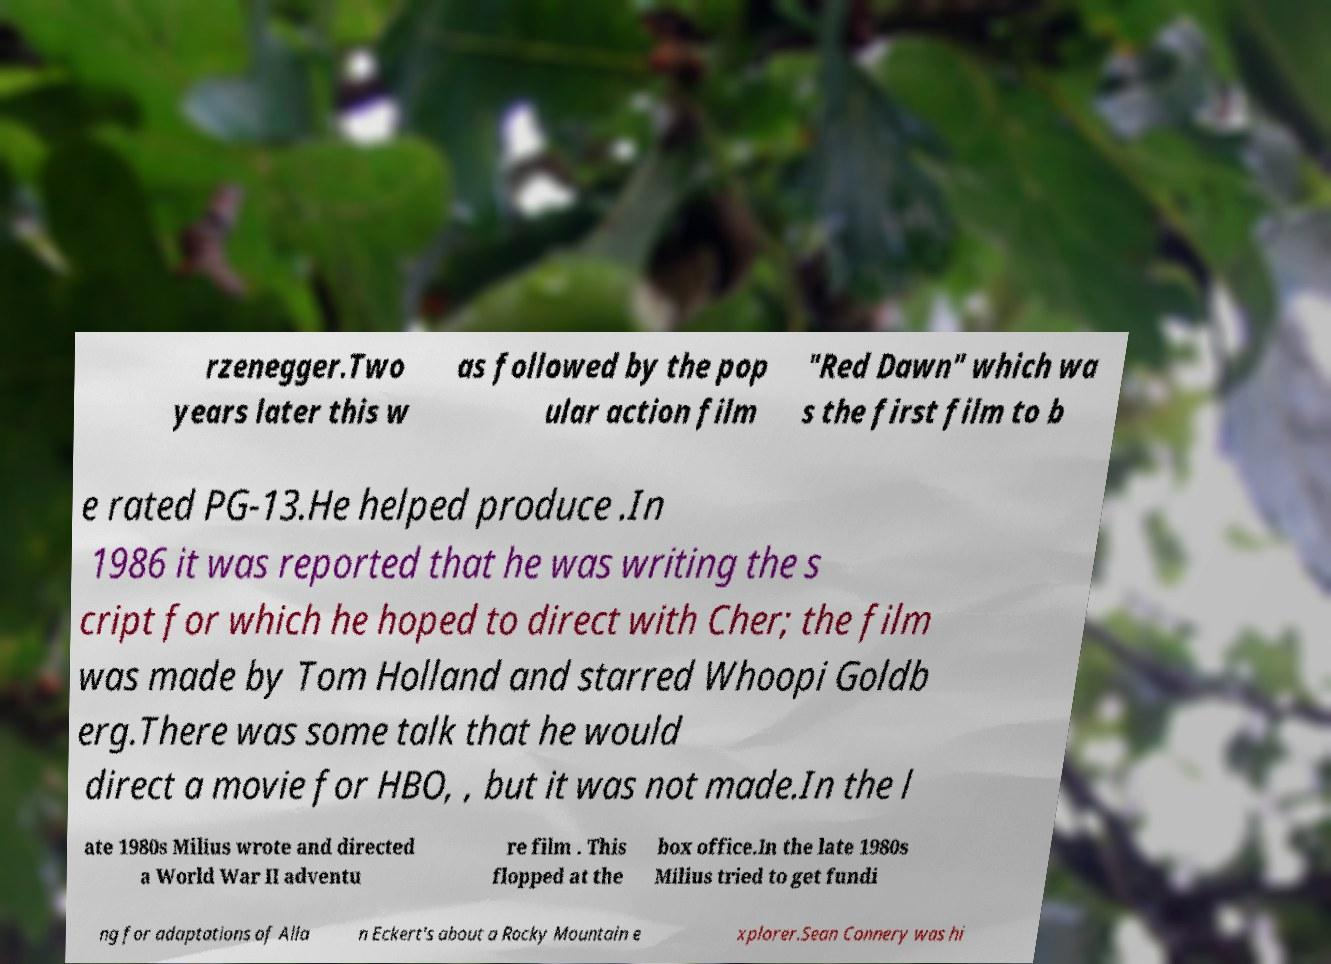What messages or text are displayed in this image? I need them in a readable, typed format. rzenegger.Two years later this w as followed by the pop ular action film "Red Dawn" which wa s the first film to b e rated PG-13.He helped produce .In 1986 it was reported that he was writing the s cript for which he hoped to direct with Cher; the film was made by Tom Holland and starred Whoopi Goldb erg.There was some talk that he would direct a movie for HBO, , but it was not made.In the l ate 1980s Milius wrote and directed a World War II adventu re film . This flopped at the box office.In the late 1980s Milius tried to get fundi ng for adaptations of Alla n Eckert's about a Rocky Mountain e xplorer.Sean Connery was hi 